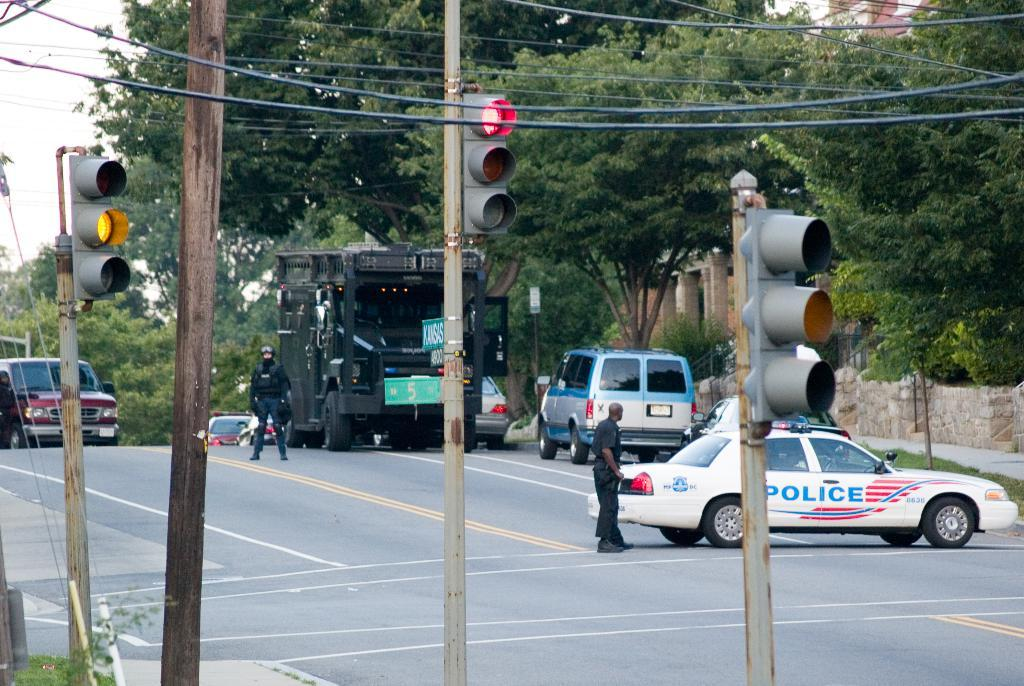<image>
Relay a brief, clear account of the picture shown. An intersection, 5th and Kansas, with a police car, 8638, blocking the road. 